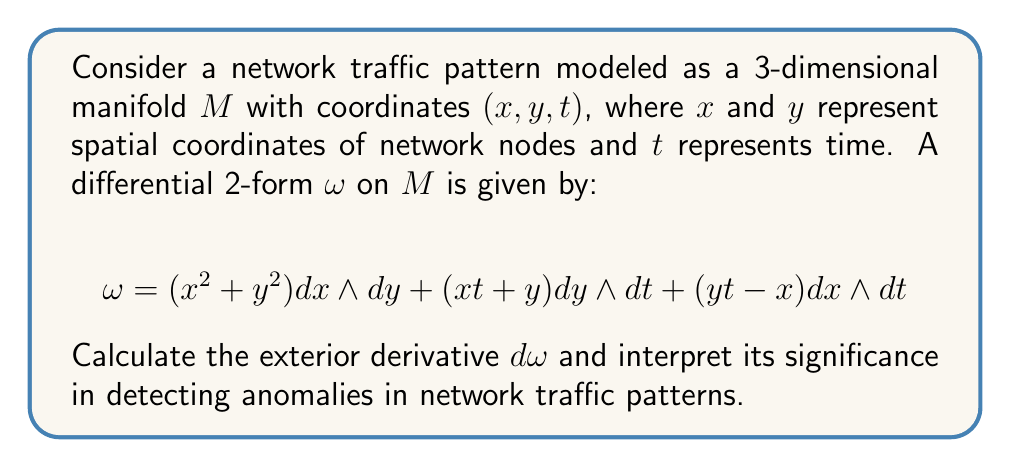Teach me how to tackle this problem. To solve this problem, we'll follow these steps:

1) Recall the formula for the exterior derivative of a 2-form in 3 dimensions:
   For $\omega = f dx \wedge dy + g dy \wedge dt + h dx \wedge dt$,
   $$d\omega = (\frac{\partial f}{\partial t} + \frac{\partial g}{\partial x} + \frac{\partial h}{\partial y}) dx \wedge dy \wedge dt$$

2) Identify the components of our 2-form:
   $f = x^2 + y^2$
   $g = xt + y$
   $h = yt - x$

3) Calculate the partial derivatives:
   $\frac{\partial f}{\partial t} = 0$
   $\frac{\partial g}{\partial x} = t$
   $\frac{\partial h}{\partial y} = t$

4) Sum the partial derivatives:
   $\frac{\partial f}{\partial t} + \frac{\partial g}{\partial x} + \frac{\partial h}{\partial y} = 0 + t + t = 2t$

5) Therefore, the exterior derivative is:
   $$d\omega = 2t \, dx \wedge dy \wedge dt$$

Interpretation:
The exterior derivative $d\omega$ represents the rate of change of the network traffic pattern over space and time. The fact that it's non-zero indicates the presence of variations in the traffic pattern.

The coefficient $2t$ suggests that these variations increase linearly with time. This could indicate a gradual build-up of anomalies or patterns in the network traffic.

In the context of network security:
1) A constant, non-zero $d\omega$ might represent normal network behavior with consistent changes over time.
2) Sudden spikes or drops in the magnitude of $d\omega$ could indicate potential anomalies or security threats.
3) The spatial components ($dx$ and $dy$) allow for localization of these changes to specific areas of the network.

By monitoring $d\omega$, security professionals can detect and analyze unusual patterns or anomalies in network traffic, potentially identifying security threats or performance issues before they become critical.
Answer: $$d\omega = 2t \, dx \wedge dy \wedge dt$$ 